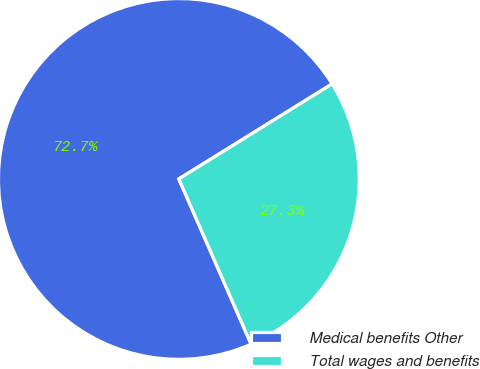Convert chart to OTSL. <chart><loc_0><loc_0><loc_500><loc_500><pie_chart><fcel>Medical benefits Other<fcel>Total wages and benefits<nl><fcel>72.73%<fcel>27.27%<nl></chart> 